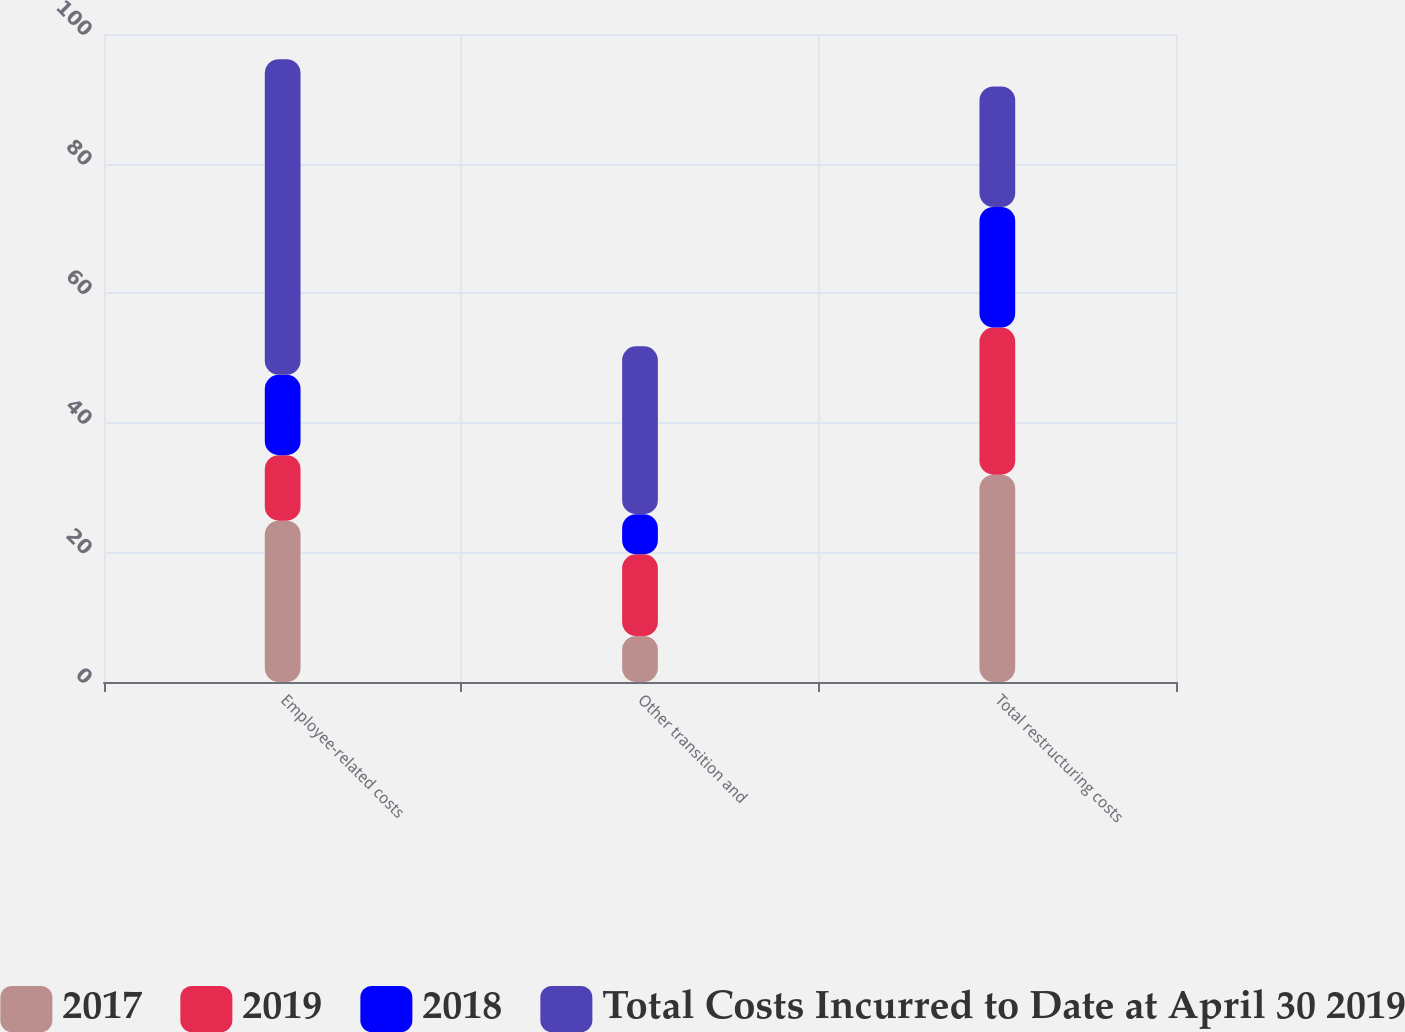Convert chart to OTSL. <chart><loc_0><loc_0><loc_500><loc_500><stacked_bar_chart><ecel><fcel>Employee-related costs<fcel>Other transition and<fcel>Total restructuring costs<nl><fcel>2017<fcel>24.9<fcel>7.1<fcel>32<nl><fcel>2019<fcel>10.1<fcel>12.6<fcel>22.7<nl><fcel>2018<fcel>12.4<fcel>6.2<fcel>18.6<nl><fcel>Total Costs Incurred to Date at April 30 2019<fcel>48.7<fcel>25.9<fcel>18.6<nl></chart> 